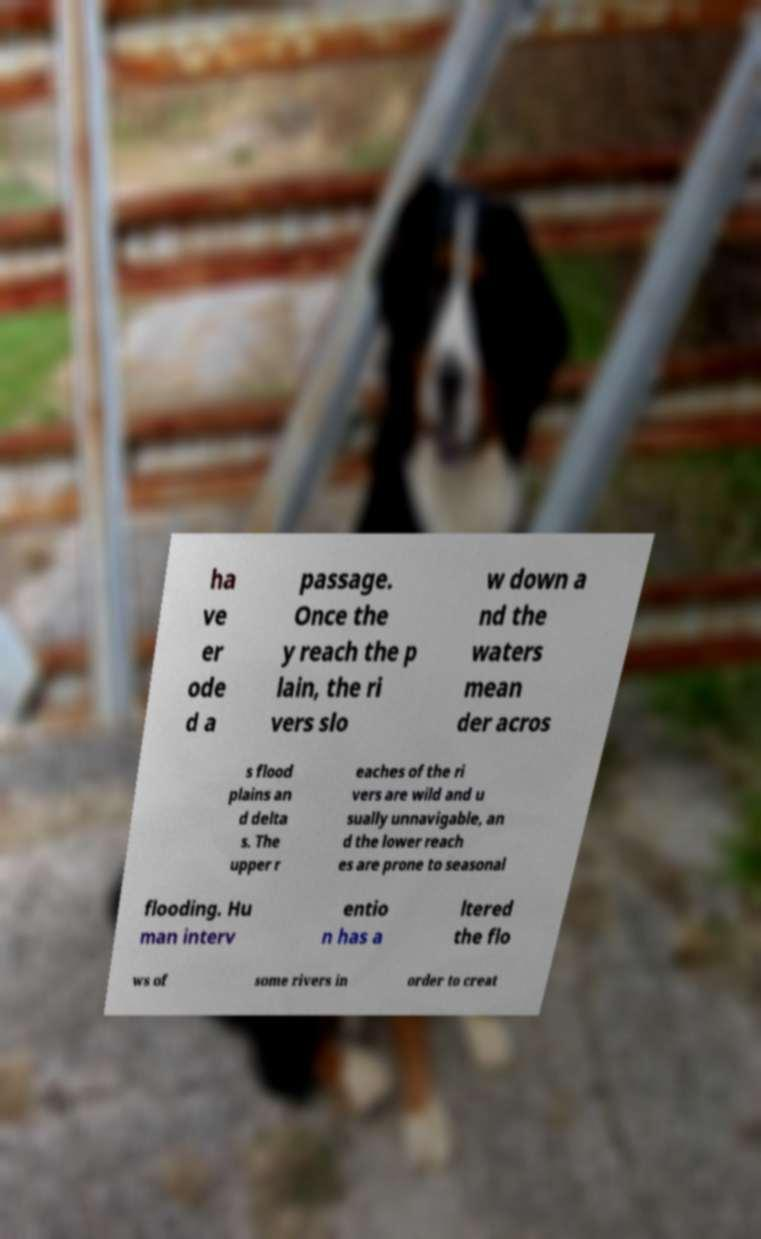Can you read and provide the text displayed in the image?This photo seems to have some interesting text. Can you extract and type it out for me? ha ve er ode d a passage. Once the y reach the p lain, the ri vers slo w down a nd the waters mean der acros s flood plains an d delta s. The upper r eaches of the ri vers are wild and u sually unnavigable, an d the lower reach es are prone to seasonal flooding. Hu man interv entio n has a ltered the flo ws of some rivers in order to creat 